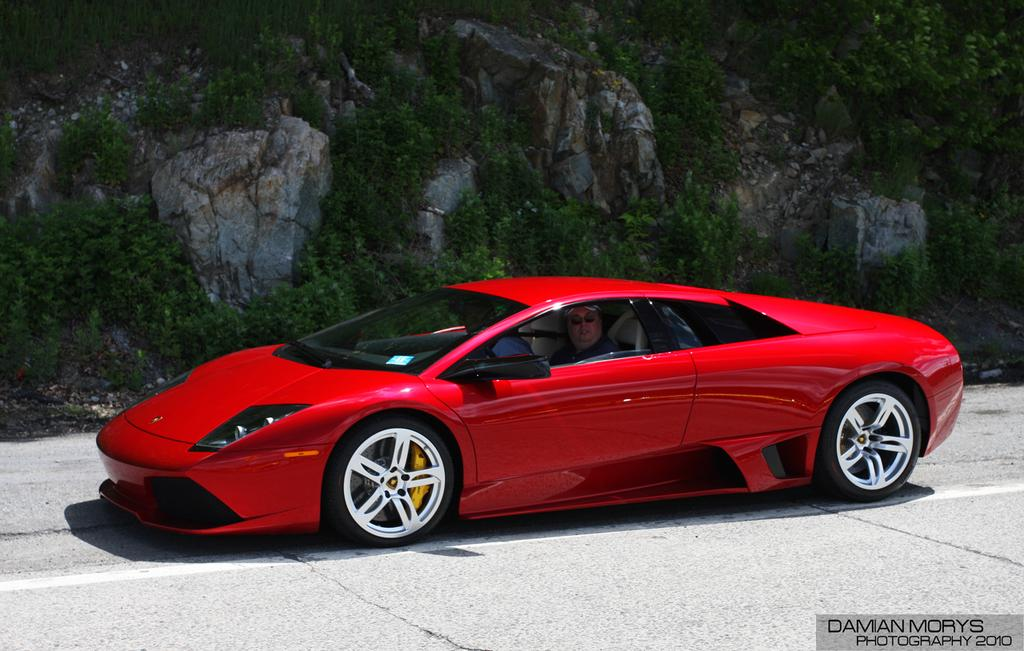How many people are in the image? There are two men in the image. What are the men doing in the image? The men are sitting in a red color car. Where is the car located in the image? The car is on the road. What can be seen in the background of the image? There are hills in the background of the image, with stones and plants on them. What type of bells can be heard ringing in the image? There are no bells present in the image, and therefore no sound can be heard. 